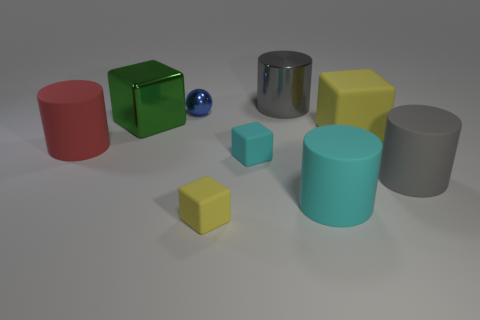Subtract all small cyan rubber cubes. How many cubes are left? 3 Subtract all gray balls. How many gray cylinders are left? 2 Subtract all green cubes. How many cubes are left? 3 Add 1 tiny gray balls. How many objects exist? 10 Subtract all cubes. How many objects are left? 5 Add 3 tiny yellow rubber cubes. How many tiny yellow rubber cubes are left? 4 Add 8 big yellow things. How many big yellow things exist? 9 Subtract 0 yellow spheres. How many objects are left? 9 Subtract all brown cylinders. Subtract all cyan spheres. How many cylinders are left? 4 Subtract all big green shiny objects. Subtract all yellow matte blocks. How many objects are left? 6 